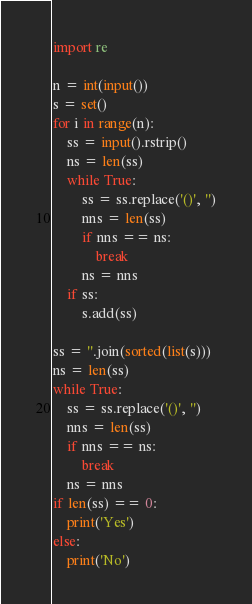Convert code to text. <code><loc_0><loc_0><loc_500><loc_500><_Python_>import re

n = int(input())
s = set()
for i in range(n):
    ss = input().rstrip()
    ns = len(ss)
    while True:
        ss = ss.replace('()', '')
        nns = len(ss)
        if nns == ns:
            break
        ns = nns
    if ss:
        s.add(ss)

ss = ''.join(sorted(list(s)))
ns = len(ss)
while True:
    ss = ss.replace('()', '')
    nns = len(ss)
    if nns == ns:
        break
    ns = nns
if len(ss) == 0:
    print('Yes')
else:
    print('No')</code> 